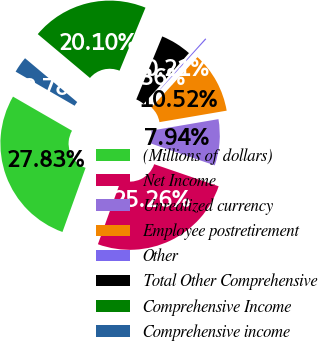<chart> <loc_0><loc_0><loc_500><loc_500><pie_chart><fcel>(Millions of dollars)<fcel>Net Income<fcel>Unrealized currency<fcel>Employee postretirement<fcel>Other<fcel>Total Other Comprehensive<fcel>Comprehensive Income<fcel>Comprehensive income<nl><fcel>27.83%<fcel>25.26%<fcel>7.94%<fcel>10.52%<fcel>0.21%<fcel>5.36%<fcel>20.1%<fcel>2.78%<nl></chart> 